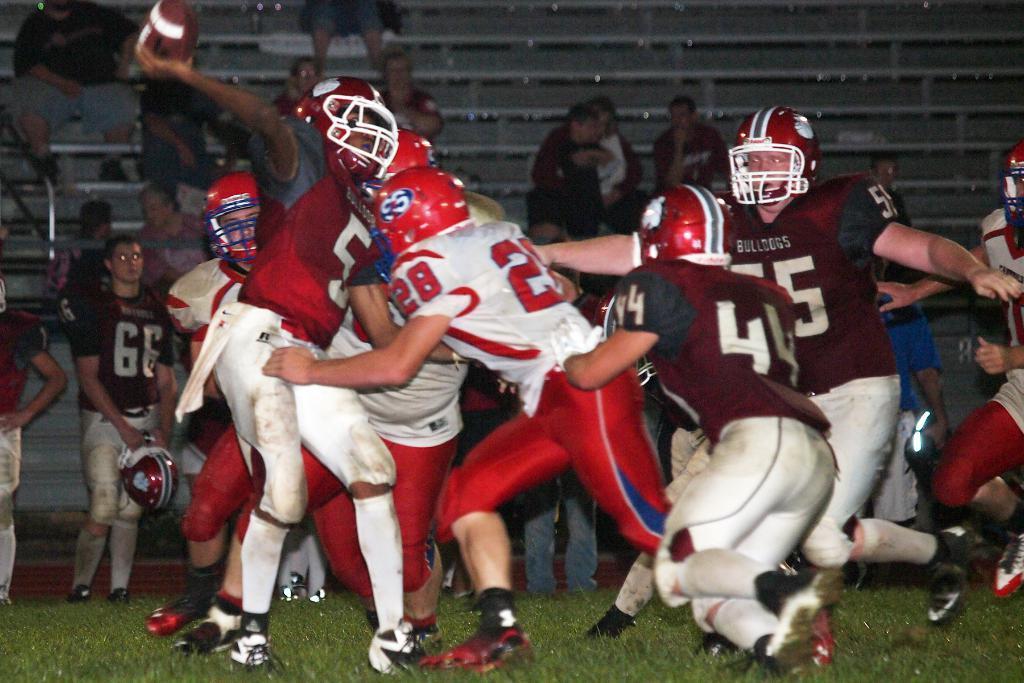Please provide a concise description of this image. The picture is taken during night time. In the foreground of the picture we can see people playing rugby in a grass court. In the background there are benches, audience and people. 